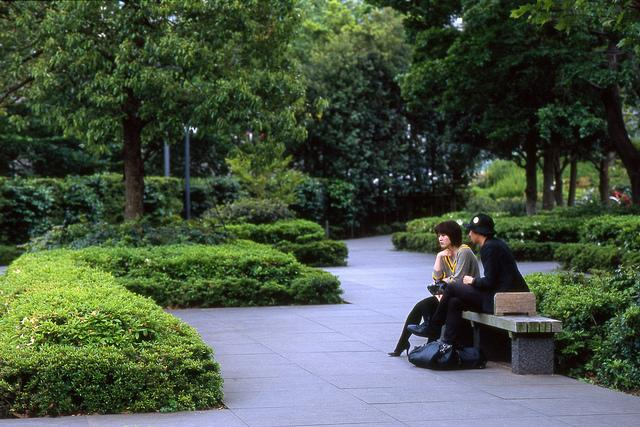How many people are sitting on the bench in the middle of the park?

Choices:
A) two
B) four
C) five
D) three two 